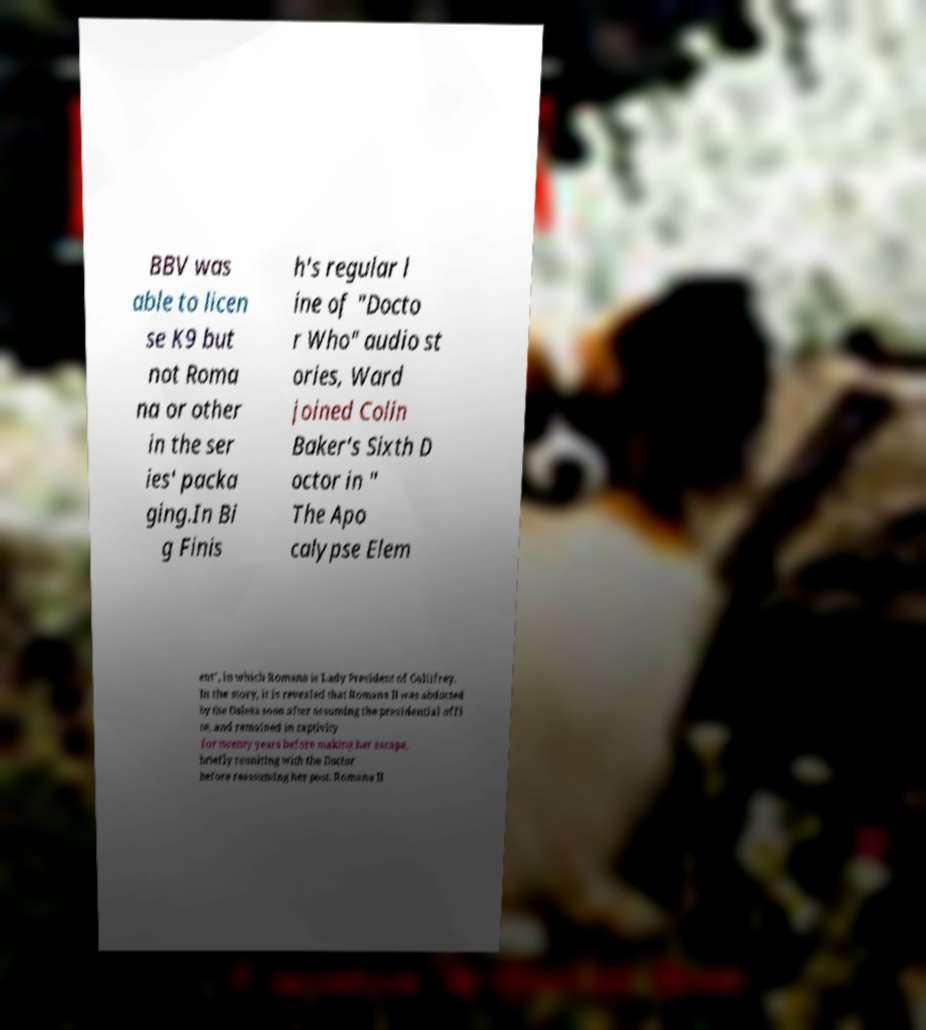Could you assist in decoding the text presented in this image and type it out clearly? BBV was able to licen se K9 but not Roma na or other in the ser ies' packa ging.In Bi g Finis h's regular l ine of "Docto r Who" audio st ories, Ward joined Colin Baker's Sixth D octor in " The Apo calypse Elem ent", in which Romana is Lady President of Gallifrey. In the story, it is revealed that Romana II was abducted by the Daleks soon after assuming the presidential offi ce, and remained in captivity for twenty years before making her escape, briefly reuniting with the Doctor before reassuming her post. Romana II 